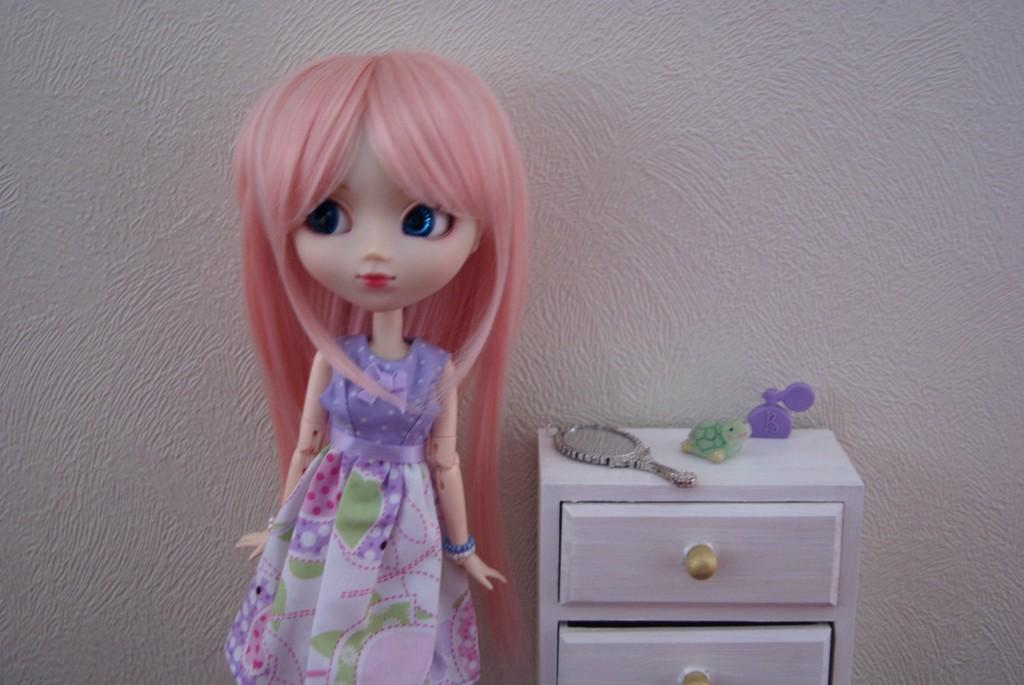What is the main subject in the image? There is a doll in the image. What type of storage can be seen in the image? There are cupboard racks with handles in the image. What other items are present in the image? There are toys in the image. What is used for reflection in the image? There is a mirror in the image. What color is the wall in the background of the image? There is a white wall in the background of the image. How many boats are visible in the image? There are no boats present in the image. What type of yam is being used as a toy in the image? There is no yam present in the image, and no yam is being used as a toy. 